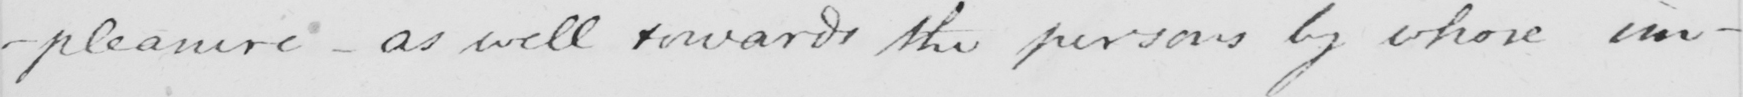Can you read and transcribe this handwriting? -pleasure  _  as well rewards the persons by whose im- 